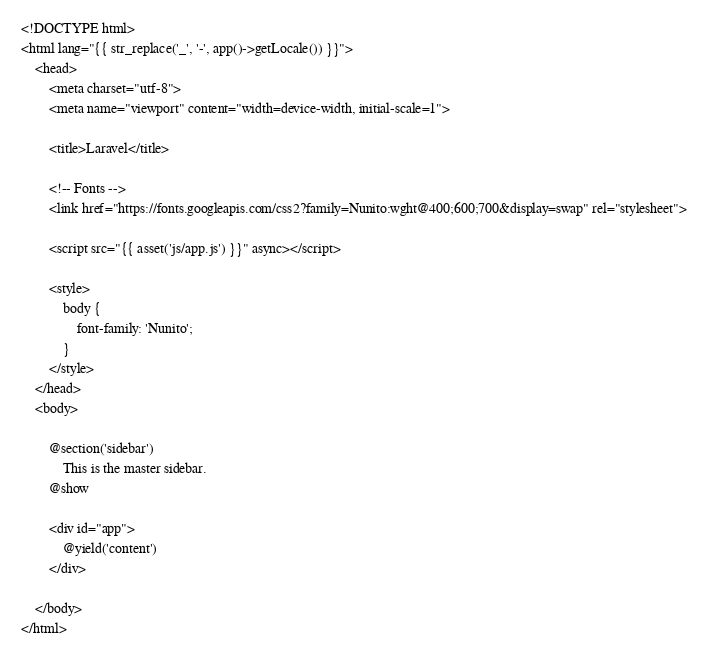Convert code to text. <code><loc_0><loc_0><loc_500><loc_500><_PHP_><!DOCTYPE html>
<html lang="{{ str_replace('_', '-', app()->getLocale()) }}">
    <head>
        <meta charset="utf-8">
        <meta name="viewport" content="width=device-width, initial-scale=1">

        <title>Laravel</title>

        <!-- Fonts -->
        <link href="https://fonts.googleapis.com/css2?family=Nunito:wght@400;600;700&display=swap" rel="stylesheet">

        <script src="{{ asset('js/app.js') }}" async></script>

        <style>
            body {
                font-family: 'Nunito';
            }
        </style>
    </head>
    <body>

        @section('sidebar')
            This is the master sidebar.
        @show

        <div id="app">
            @yield('content')
        </div>
        
    </body>
</html>
</code> 